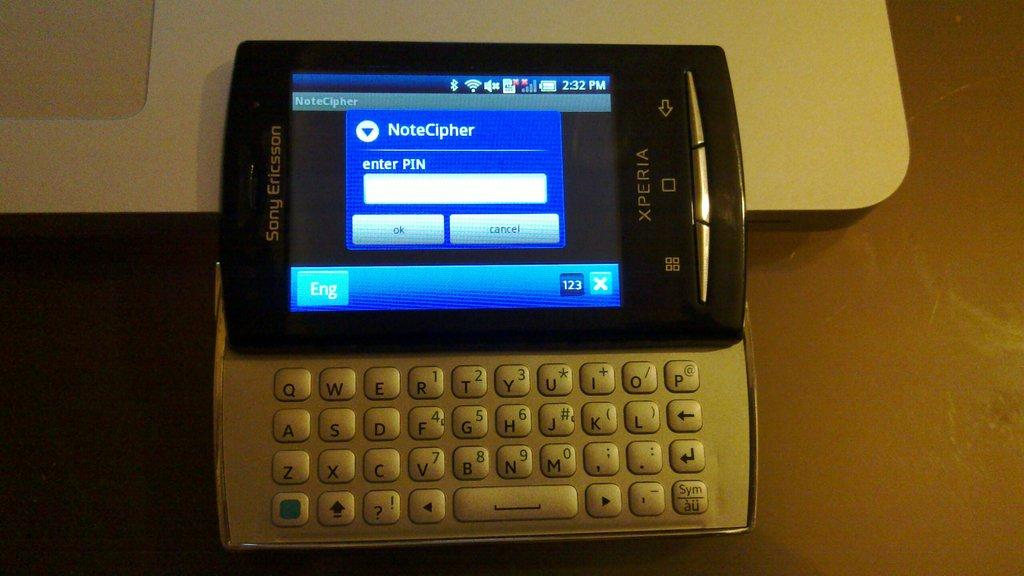<image>
Present a compact description of the photo's key features. a sony ericsson cell phone with a attached keyboard 